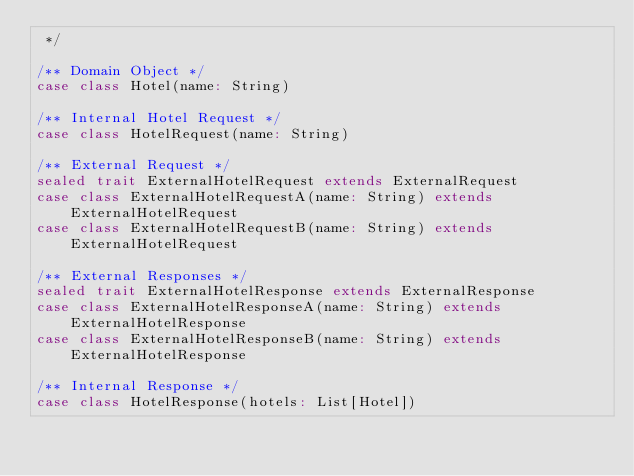<code> <loc_0><loc_0><loc_500><loc_500><_Scala_> */

/** Domain Object */
case class Hotel(name: String)

/** Internal Hotel Request */
case class HotelRequest(name: String)

/** External Request */
sealed trait ExternalHotelRequest extends ExternalRequest
case class ExternalHotelRequestA(name: String) extends ExternalHotelRequest
case class ExternalHotelRequestB(name: String) extends ExternalHotelRequest

/** External Responses */
sealed trait ExternalHotelResponse extends ExternalResponse
case class ExternalHotelResponseA(name: String) extends ExternalHotelResponse
case class ExternalHotelResponseB(name: String) extends ExternalHotelResponse

/** Internal Response */
case class HotelResponse(hotels: List[Hotel])
</code> 